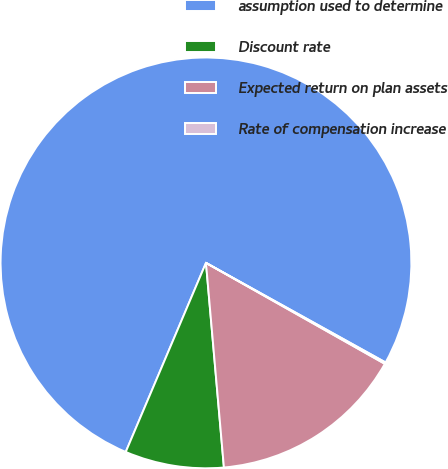<chart> <loc_0><loc_0><loc_500><loc_500><pie_chart><fcel>assumption used to determine<fcel>Discount rate<fcel>Expected return on plan assets<fcel>Rate of compensation increase<nl><fcel>76.67%<fcel>7.78%<fcel>15.43%<fcel>0.12%<nl></chart> 